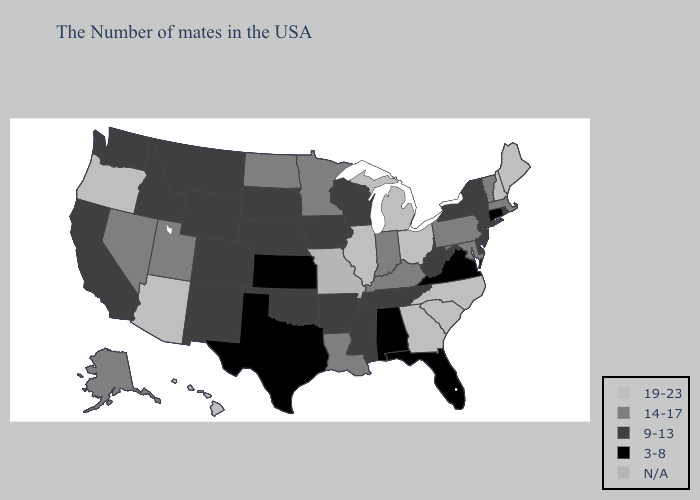Which states hav the highest value in the MidWest?
Short answer required. Ohio, Michigan, Illinois. Does Rhode Island have the lowest value in the Northeast?
Write a very short answer. No. What is the highest value in the South ?
Short answer required. 19-23. Name the states that have a value in the range N/A?
Keep it brief. Missouri. What is the value of Illinois?
Give a very brief answer. 19-23. Name the states that have a value in the range 19-23?
Short answer required. Maine, New Hampshire, North Carolina, South Carolina, Ohio, Georgia, Michigan, Illinois, Arizona, Oregon, Hawaii. What is the value of Nevada?
Keep it brief. 14-17. What is the lowest value in the USA?
Answer briefly. 3-8. Does Idaho have the highest value in the West?
Short answer required. No. Name the states that have a value in the range 19-23?
Answer briefly. Maine, New Hampshire, North Carolina, South Carolina, Ohio, Georgia, Michigan, Illinois, Arizona, Oregon, Hawaii. Which states have the lowest value in the USA?
Write a very short answer. Connecticut, Virginia, Florida, Alabama, Kansas, Texas. Name the states that have a value in the range 9-13?
Answer briefly. Rhode Island, New York, New Jersey, Delaware, West Virginia, Tennessee, Wisconsin, Mississippi, Arkansas, Iowa, Nebraska, Oklahoma, South Dakota, Wyoming, Colorado, New Mexico, Montana, Idaho, California, Washington. What is the value of Georgia?
Quick response, please. 19-23. What is the highest value in the USA?
Write a very short answer. 19-23. Does the first symbol in the legend represent the smallest category?
Keep it brief. No. 